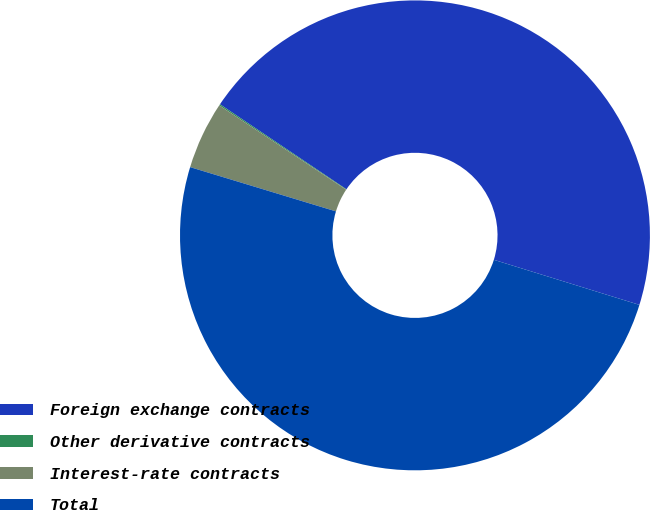<chart> <loc_0><loc_0><loc_500><loc_500><pie_chart><fcel>Foreign exchange contracts<fcel>Other derivative contracts<fcel>Interest-rate contracts<fcel>Total<nl><fcel>45.36%<fcel>0.09%<fcel>4.64%<fcel>49.91%<nl></chart> 